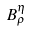Convert formula to latex. <formula><loc_0><loc_0><loc_500><loc_500>B _ { \rho } ^ { \eta }</formula> 